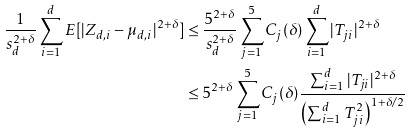Convert formula to latex. <formula><loc_0><loc_0><loc_500><loc_500>\frac { 1 } { s _ { d } ^ { 2 + \delta } } \sum _ { i = 1 } ^ { d } E [ | Z _ { d , i } - \mu _ { d , i } | ^ { 2 + \delta } ] & \leq \frac { 5 ^ { 2 + \delta } } { s _ { d } ^ { 2 + \delta } } \sum _ { j = 1 } ^ { 5 } C _ { j } ( \delta ) \sum _ { i = 1 } ^ { d } | T _ { j i } | ^ { 2 + \delta } \\ & \leq 5 ^ { 2 + \delta } \sum _ { j = 1 } ^ { 5 } C _ { j } ( \delta ) \frac { \sum _ { i = 1 } ^ { d } | T _ { j i } | ^ { 2 + \delta } } { \left ( \sum _ { i = 1 } ^ { d } T _ { j i } ^ { 2 } \right ) ^ { 1 + \delta / 2 } }</formula> 